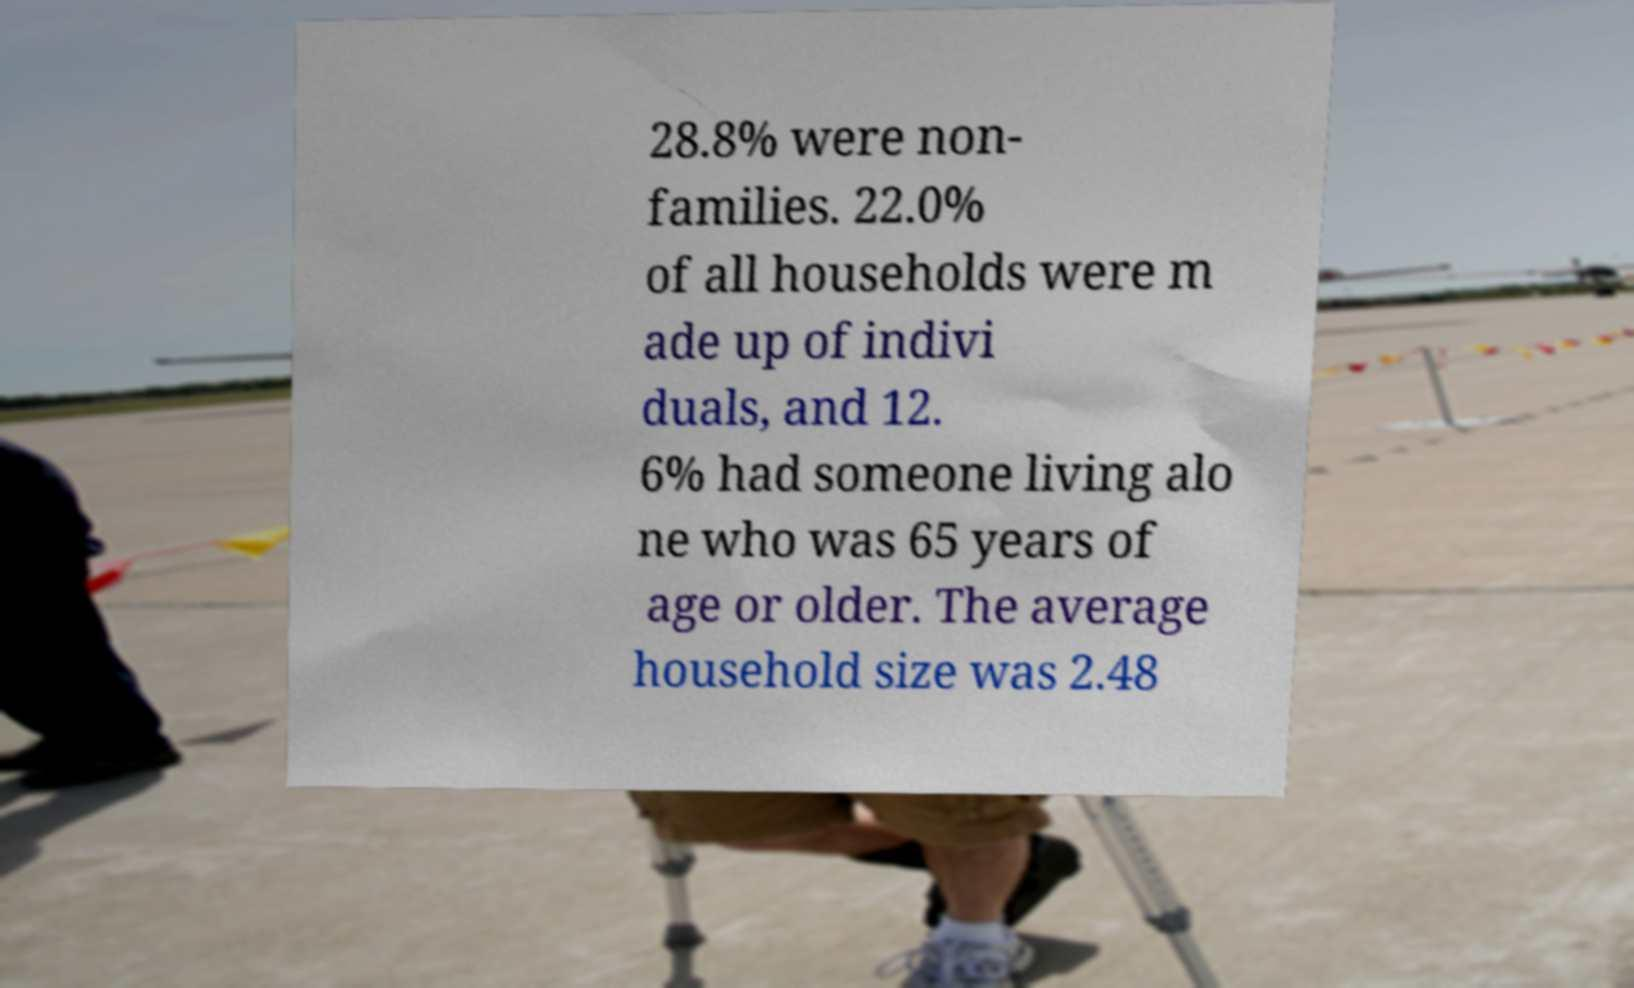Can you read and provide the text displayed in the image?This photo seems to have some interesting text. Can you extract and type it out for me? 28.8% were non- families. 22.0% of all households were m ade up of indivi duals, and 12. 6% had someone living alo ne who was 65 years of age or older. The average household size was 2.48 